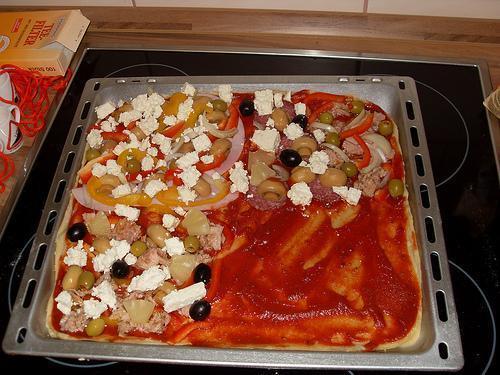How many black olives are in the picture?
Give a very brief answer. 7. How many quarters of the pizza do not have vegetables?
Give a very brief answer. 1. 